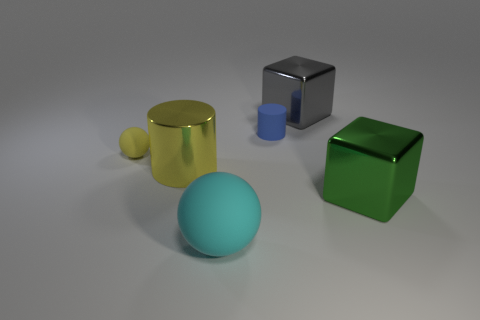There is a gray thing; does it have the same size as the cyan matte sphere in front of the rubber cylinder?
Keep it short and to the point. Yes. The object that is in front of the large shiny cylinder and to the right of the tiny rubber cylinder is what color?
Your answer should be very brief. Green. There is a large metallic cube in front of the yellow rubber sphere; are there any large spheres to the left of it?
Your answer should be compact. Yes. Are there an equal number of metal objects behind the big green shiny block and balls?
Keep it short and to the point. Yes. There is a shiny object on the right side of the cube that is behind the yellow sphere; how many green metal blocks are left of it?
Provide a short and direct response. 0. Are there any other metal cubes of the same size as the green cube?
Keep it short and to the point. Yes. Is the number of yellow cylinders in front of the cyan sphere less than the number of brown matte cylinders?
Keep it short and to the point. No. The object that is in front of the big block that is on the right side of the large cube behind the yellow metallic cylinder is made of what material?
Your answer should be compact. Rubber. Is the number of small balls on the right side of the big cyan rubber ball greater than the number of yellow shiny things behind the yellow shiny cylinder?
Make the answer very short. No. What number of matte things are either tiny purple spheres or small things?
Offer a very short reply. 2. 